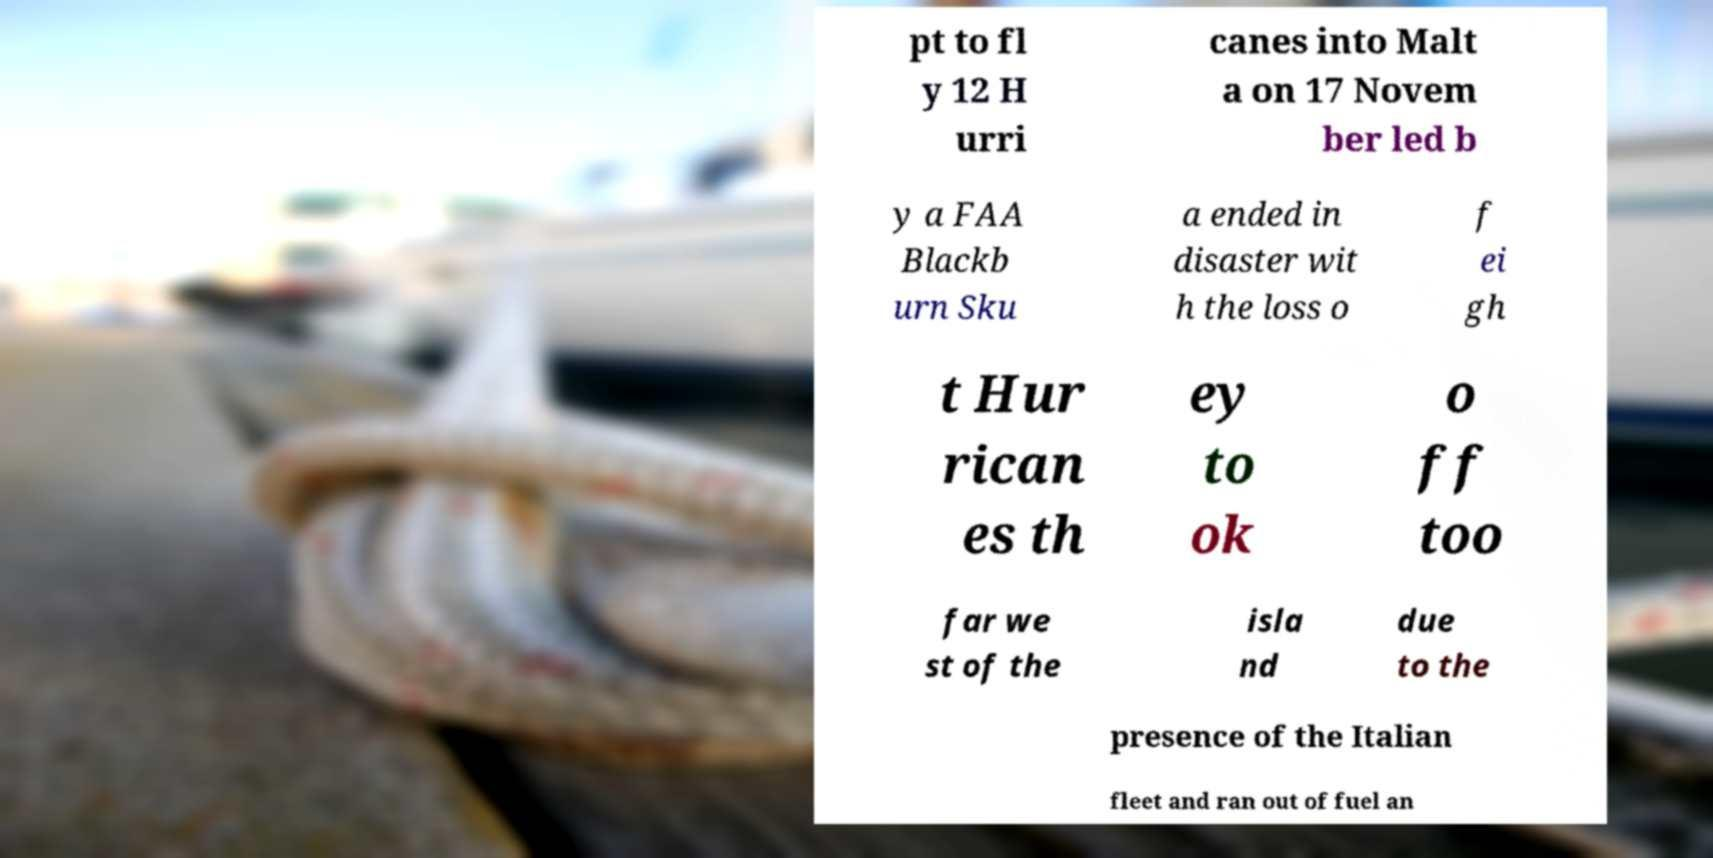What messages or text are displayed in this image? I need them in a readable, typed format. pt to fl y 12 H urri canes into Malt a on 17 Novem ber led b y a FAA Blackb urn Sku a ended in disaster wit h the loss o f ei gh t Hur rican es th ey to ok o ff too far we st of the isla nd due to the presence of the Italian fleet and ran out of fuel an 